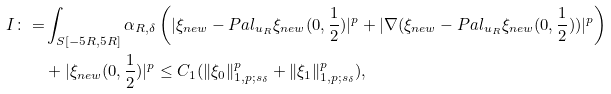<formula> <loc_0><loc_0><loc_500><loc_500>I \colon = & \int _ { S [ - 5 R , 5 R ] } \alpha _ { R , \delta } \left ( | \xi _ { n e w } - P a l _ { u _ { R } } \xi _ { n e w } ( 0 , \frac { 1 } { 2 } ) | ^ { p } + | \nabla ( \xi _ { n e w } - P a l _ { u _ { R } } \xi _ { n e w } ( 0 , \frac { 1 } { 2 } ) ) | ^ { p } \right ) \\ & + | \xi _ { n e w } ( 0 , \frac { 1 } { 2 } ) | ^ { p } \leq C _ { 1 } ( \| \xi _ { 0 } \| _ { 1 , p ; s _ { \delta } } ^ { p } + \| \xi _ { 1 } \| _ { 1 , p ; s _ { \delta } } ^ { p } ) ,</formula> 